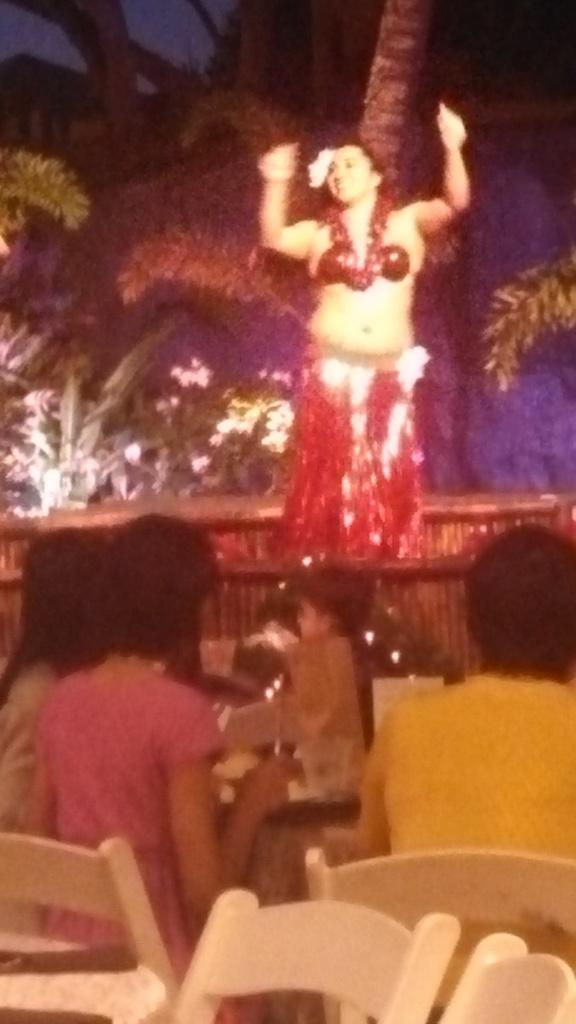What are the people in the image doing? There is a group of people sitting on chairs in the image. What is happening in the background of the image? There is a person dancing on a stage in the background of the image. What can be seen in the distance in the image? Trees and the sky are visible in the background of the image. What type of chalk is the person using to teach in the image? There is no person teaching or using chalk in the image. 